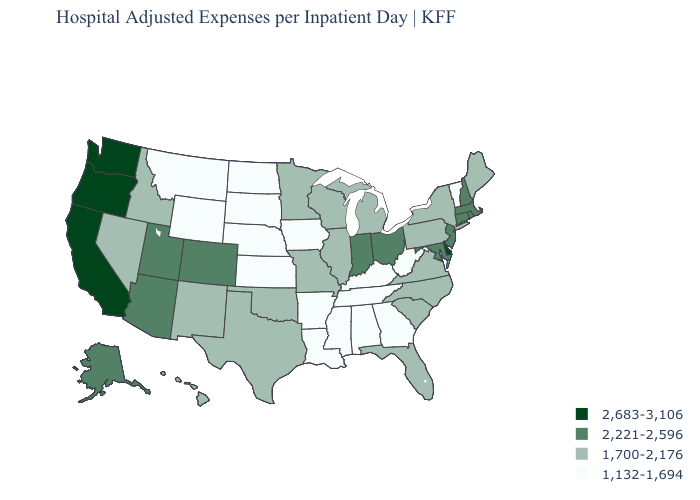Does Maine have a lower value than New Jersey?
Quick response, please. Yes. Does the first symbol in the legend represent the smallest category?
Keep it brief. No. Which states hav the highest value in the South?
Quick response, please. Delaware. What is the value of Kansas?
Keep it brief. 1,132-1,694. What is the highest value in the South ?
Give a very brief answer. 2,683-3,106. Does Delaware have the highest value in the South?
Answer briefly. Yes. Does Oregon have the same value as Hawaii?
Keep it brief. No. What is the lowest value in states that border Illinois?
Quick response, please. 1,132-1,694. Which states have the lowest value in the South?
Write a very short answer. Alabama, Arkansas, Georgia, Kentucky, Louisiana, Mississippi, Tennessee, West Virginia. What is the highest value in the MidWest ?
Keep it brief. 2,221-2,596. Does Wyoming have the same value as Alaska?
Concise answer only. No. Does Connecticut have the lowest value in the Northeast?
Concise answer only. No. Name the states that have a value in the range 1,700-2,176?
Write a very short answer. Florida, Hawaii, Idaho, Illinois, Maine, Michigan, Minnesota, Missouri, Nevada, New Mexico, New York, North Carolina, Oklahoma, Pennsylvania, South Carolina, Texas, Virginia, Wisconsin. Among the states that border Colorado , does Arizona have the highest value?
Answer briefly. Yes. Name the states that have a value in the range 1,700-2,176?
Concise answer only. Florida, Hawaii, Idaho, Illinois, Maine, Michigan, Minnesota, Missouri, Nevada, New Mexico, New York, North Carolina, Oklahoma, Pennsylvania, South Carolina, Texas, Virginia, Wisconsin. 